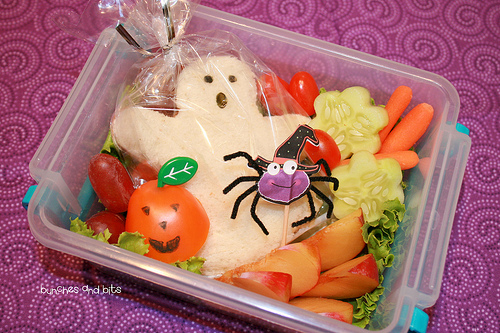<image>
Can you confirm if the spider is in the ghost? No. The spider is not contained within the ghost. These objects have a different spatial relationship. Where is the spider in relation to the apple slice? Is it behind the apple slice? Yes. From this viewpoint, the spider is positioned behind the apple slice, with the apple slice partially or fully occluding the spider. Is the spider on the ghost? Yes. Looking at the image, I can see the spider is positioned on top of the ghost, with the ghost providing support. 